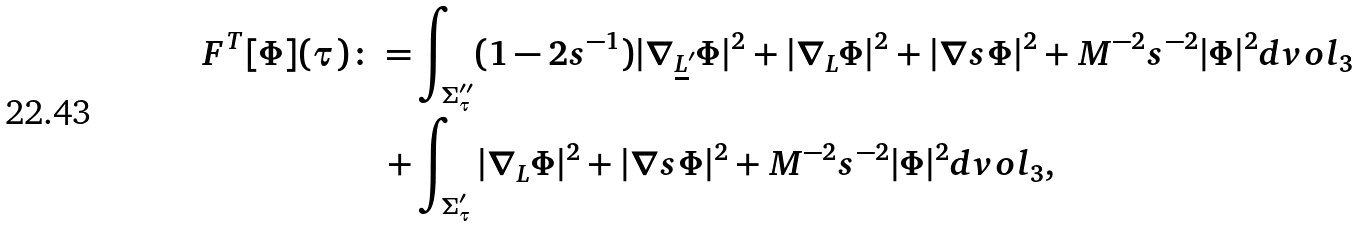Convert formula to latex. <formula><loc_0><loc_0><loc_500><loc_500>F ^ { T } [ \Phi ] ( \tau ) \colon = & \int _ { \Sigma _ { \tau } ^ { \prime \prime } } ( 1 - 2 s ^ { - 1 } ) | \nabla _ { \underline { L } ^ { \prime } } \Phi | ^ { 2 } + | \nabla _ { L } \Phi | ^ { 2 } + | \nabla s \Phi | ^ { 2 } + M ^ { - 2 } s ^ { - 2 } | \Phi | ^ { 2 } d v o l _ { 3 } \\ + & \int _ { \Sigma _ { \tau } ^ { \prime } } | \nabla _ { L } \Phi | ^ { 2 } + | \nabla s \Phi | ^ { 2 } + M ^ { - 2 } s ^ { - 2 } | \Phi | ^ { 2 } d v o l _ { 3 } ,</formula> 